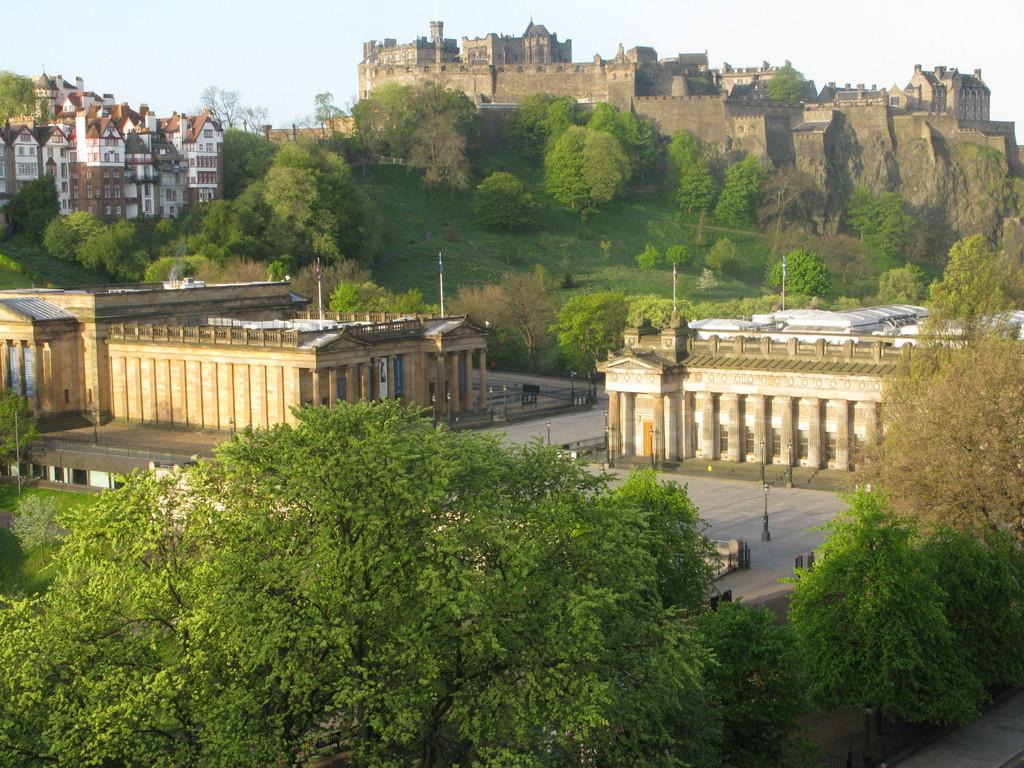What type of structures can be seen in the image? There are buildings in the image. What else can be seen in the image besides buildings? There are poles, trees, grass, and roads visible in the image. What is visible at the top of the image? The sky is visible in the image. What is the purpose of the plants in the image? There are no plants mentioned in the provided facts, so we cannot determine their purpose in the image. 